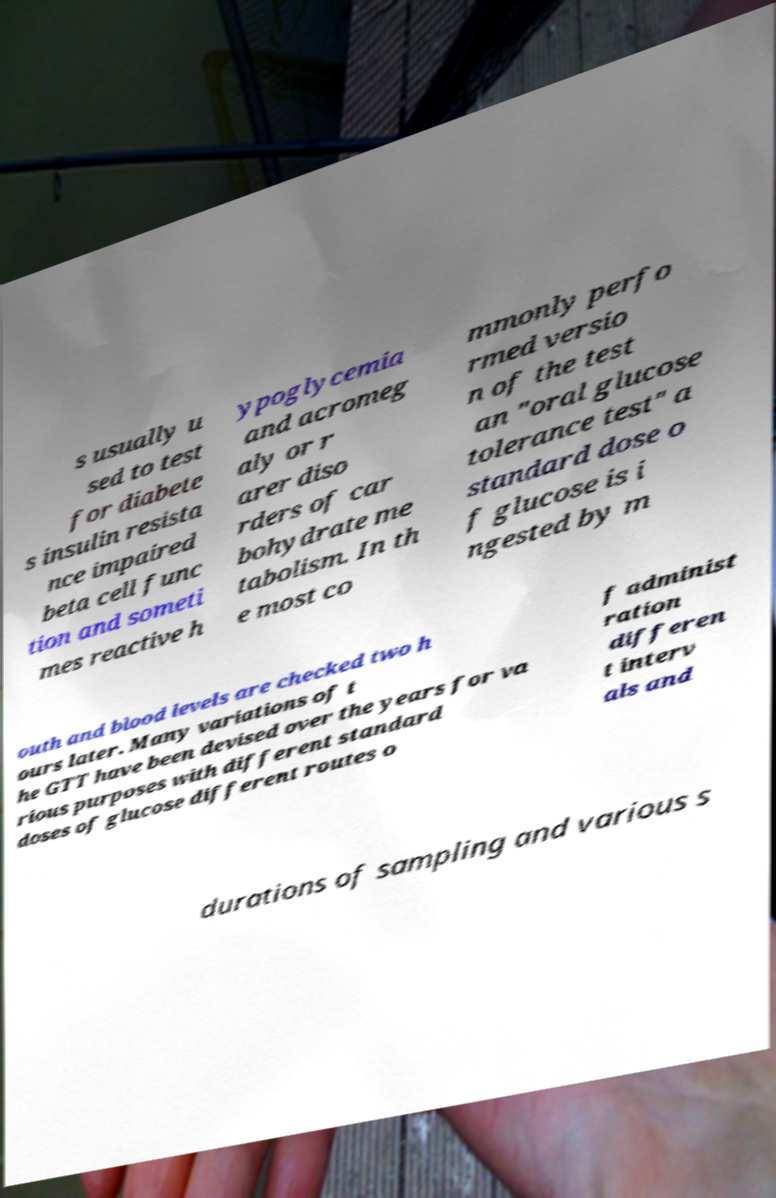Please read and relay the text visible in this image. What does it say? s usually u sed to test for diabete s insulin resista nce impaired beta cell func tion and someti mes reactive h ypoglycemia and acromeg aly or r arer diso rders of car bohydrate me tabolism. In th e most co mmonly perfo rmed versio n of the test an "oral glucose tolerance test" a standard dose o f glucose is i ngested by m outh and blood levels are checked two h ours later. Many variations of t he GTT have been devised over the years for va rious purposes with different standard doses of glucose different routes o f administ ration differen t interv als and durations of sampling and various s 